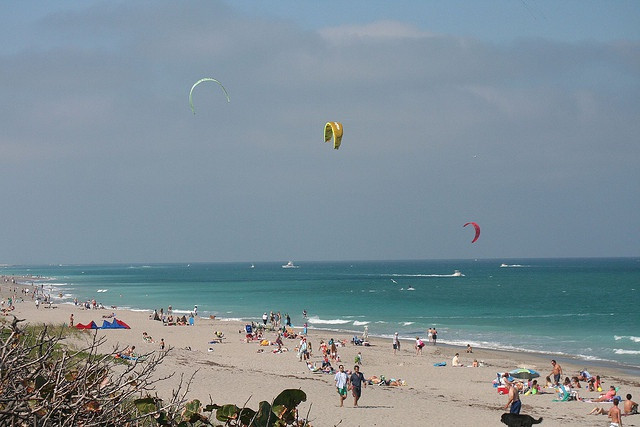Describe the objects in this image and their specific colors. I can see people in darkgray, tan, and gray tones, dog in darkgray, black, and gray tones, people in darkgray, lavender, gray, and tan tones, kite in darkgray, olive, and khaki tones, and people in darkgray, black, gray, and brown tones in this image. 